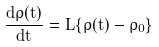<formula> <loc_0><loc_0><loc_500><loc_500>\frac { d \rho ( t ) } { d t } = \hat { \hat { L } } \{ \rho ( t ) - \rho _ { 0 } \}</formula> 